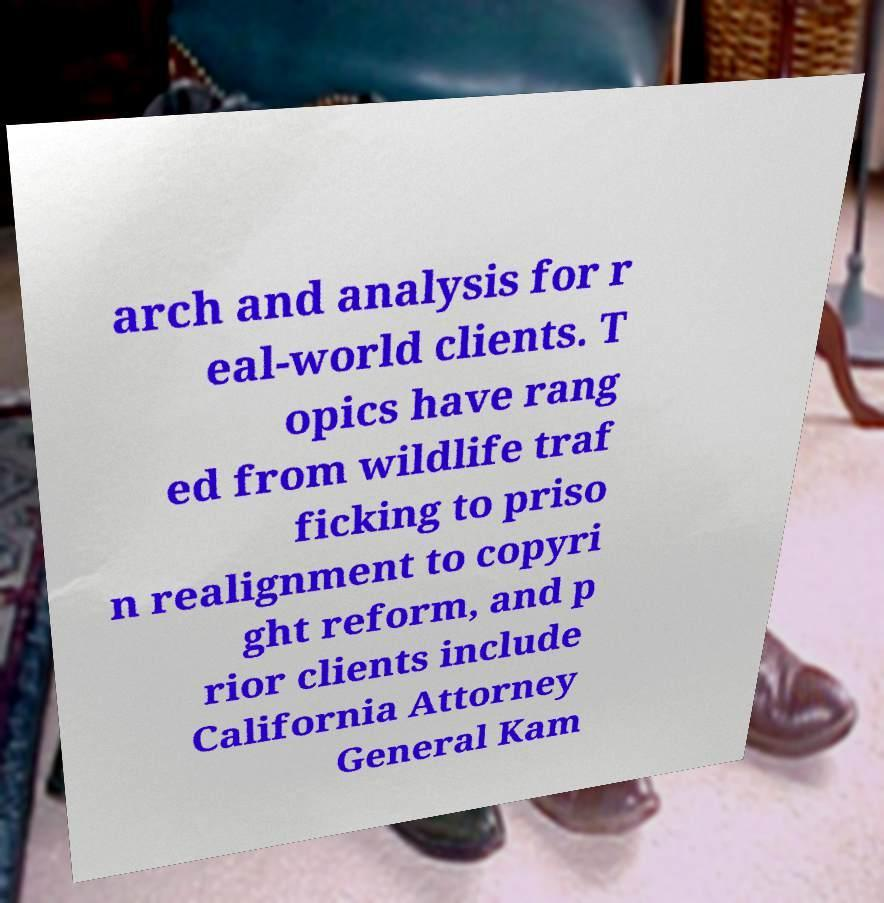Please read and relay the text visible in this image. What does it say? arch and analysis for r eal-world clients. T opics have rang ed from wildlife traf ficking to priso n realignment to copyri ght reform, and p rior clients include California Attorney General Kam 